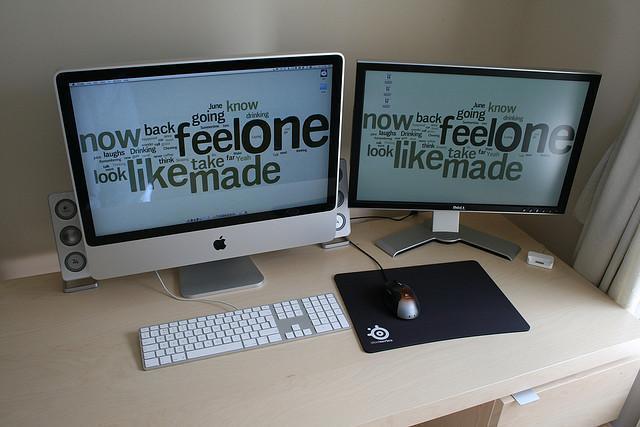How many devices are in black and white?
Give a very brief answer. 2. How many tvs are visible?
Give a very brief answer. 2. 